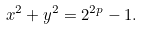Convert formula to latex. <formula><loc_0><loc_0><loc_500><loc_500>x ^ { 2 } + y ^ { 2 } = 2 ^ { 2 p } - 1 .</formula> 